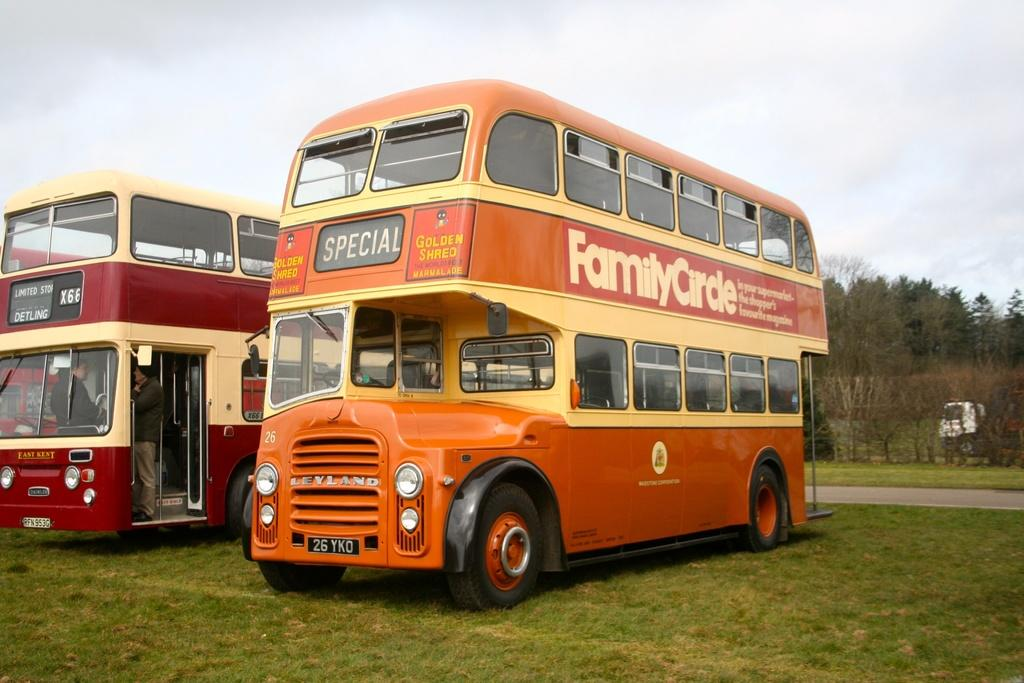<image>
Relay a brief, clear account of the picture shown. The Family Circle bus tour company operates a fleet of double deck buses. 